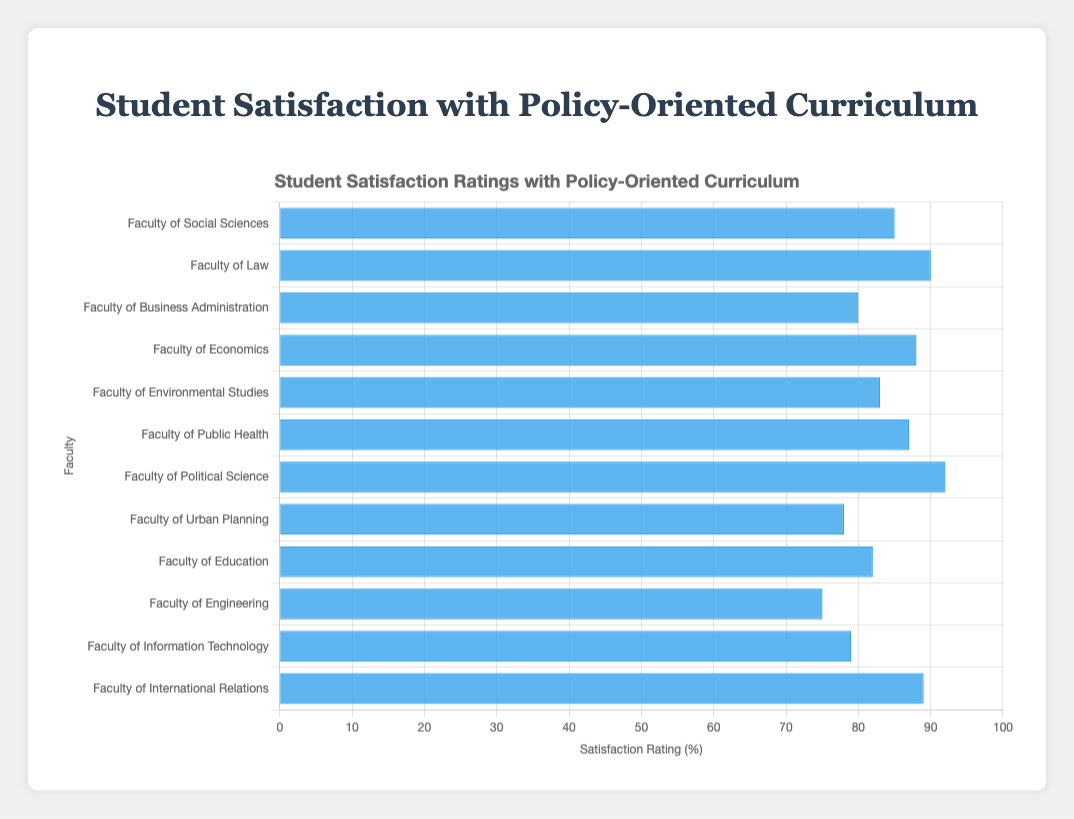Which Faculty has the highest student satisfaction rating? By looking at the horizontal bar chart, the bar for the "Faculty of Political Science" is the longest, indicating the highest rating.
Answer: Faculty of Political Science Which Faculty has the lowest student satisfaction rating? The shortest bar represents the "Faculty of Engineering," signifying the lowest rating.
Answer: Faculty of Engineering What is the difference in satisfaction ratings between the Faculty of Law and the Faculty of Engineering? The satisfaction rating for the Faculty of Law is 90 and for the Faculty of Engineering is 75. The difference is 90 - 75.
Answer: 15 Which faculties have a satisfaction rating greater than 85? By examining the bars longer than the 85 mark, the faculties are "Faculty of Law," "Faculty of Economics," "Faculty of Public Health," "Faculty of Political Science," and "Faculty of International Relations."
Answer: Faculty of Law, Faculty of Economics, Faculty of Public Health, Faculty of Political Science, Faculty of International Relations How many faculties have satisfaction ratings below 80? Count the number of bars whose endpoints are less than 80: "Faculty of Urban Planning," "Faculty of Engineering," and "Faculty of Information Technology." There are three.
Answer: 3 What is the average satisfaction rating of the Faculty of Business Administration, Faculty of Environmental Studies, and Faculty of Information Technology? The ratings are 80, 83, and 79 respectively. Calculate the average: (80 + 83 + 79) / 3 = 242 / 3.
Answer: 80.67 Which faculty has a satisfaction rating closest to 85? By comparing the ratings, the "Faculty of Social Sciences" has a satisfaction rating of 85, matching exactly.
Answer: Faculty of Social Sciences What’s the total satisfaction rating for all faculties combined? Sum all satisfaction ratings: 85 + 90 + 80 + 88 + 83 + 87 + 92 + 78 + 82 + 75 + 79 + 89. The total is 1018.
Answer: 1018 What is the overall average student satisfaction rating across all faculties? Total satisfaction rating is 1018. There are 12 faculties. The average is 1018 / 12.
Answer: 84.83 Are there more faculties with ratings above the average or below the average? The average rating is 84.83. Faculties above: 85, 90, 88, 87, 92, 89 (6 faculties). Faculties below: 80, 83, 78, 82, 75, 79 (6 faculties). The count is equal.
Answer: Equal 